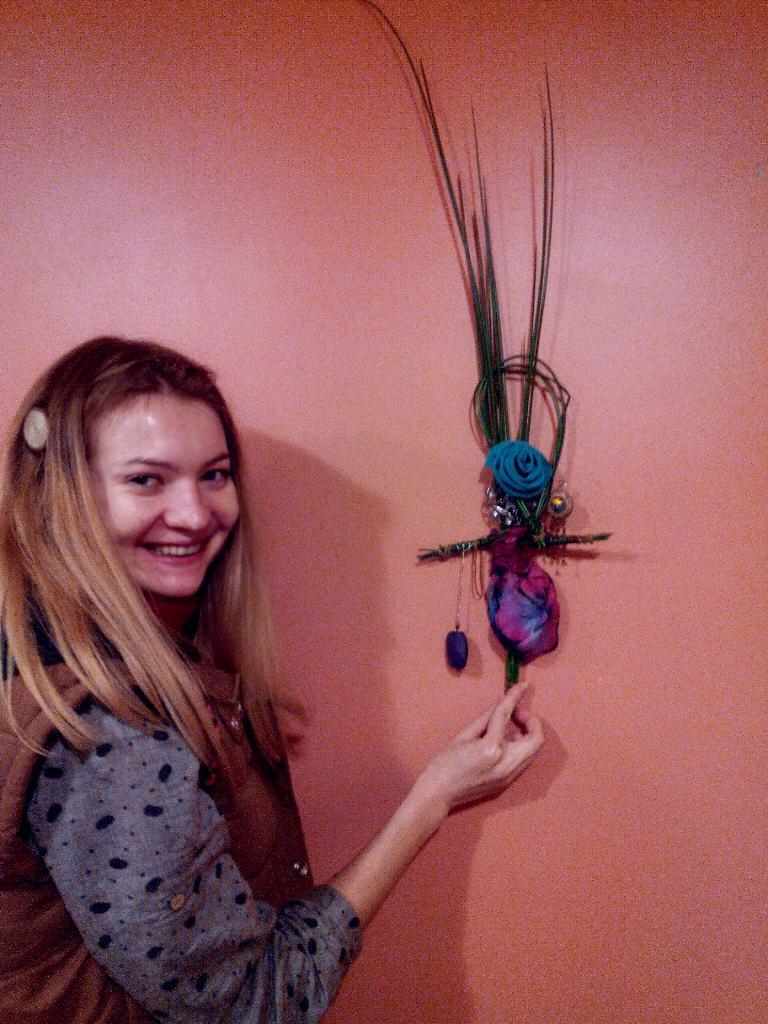How would you summarize this image in a sentence or two? In this image, we can see a woman is smiling and seeing. She is holding some decorative piece. Background there is a wall. 